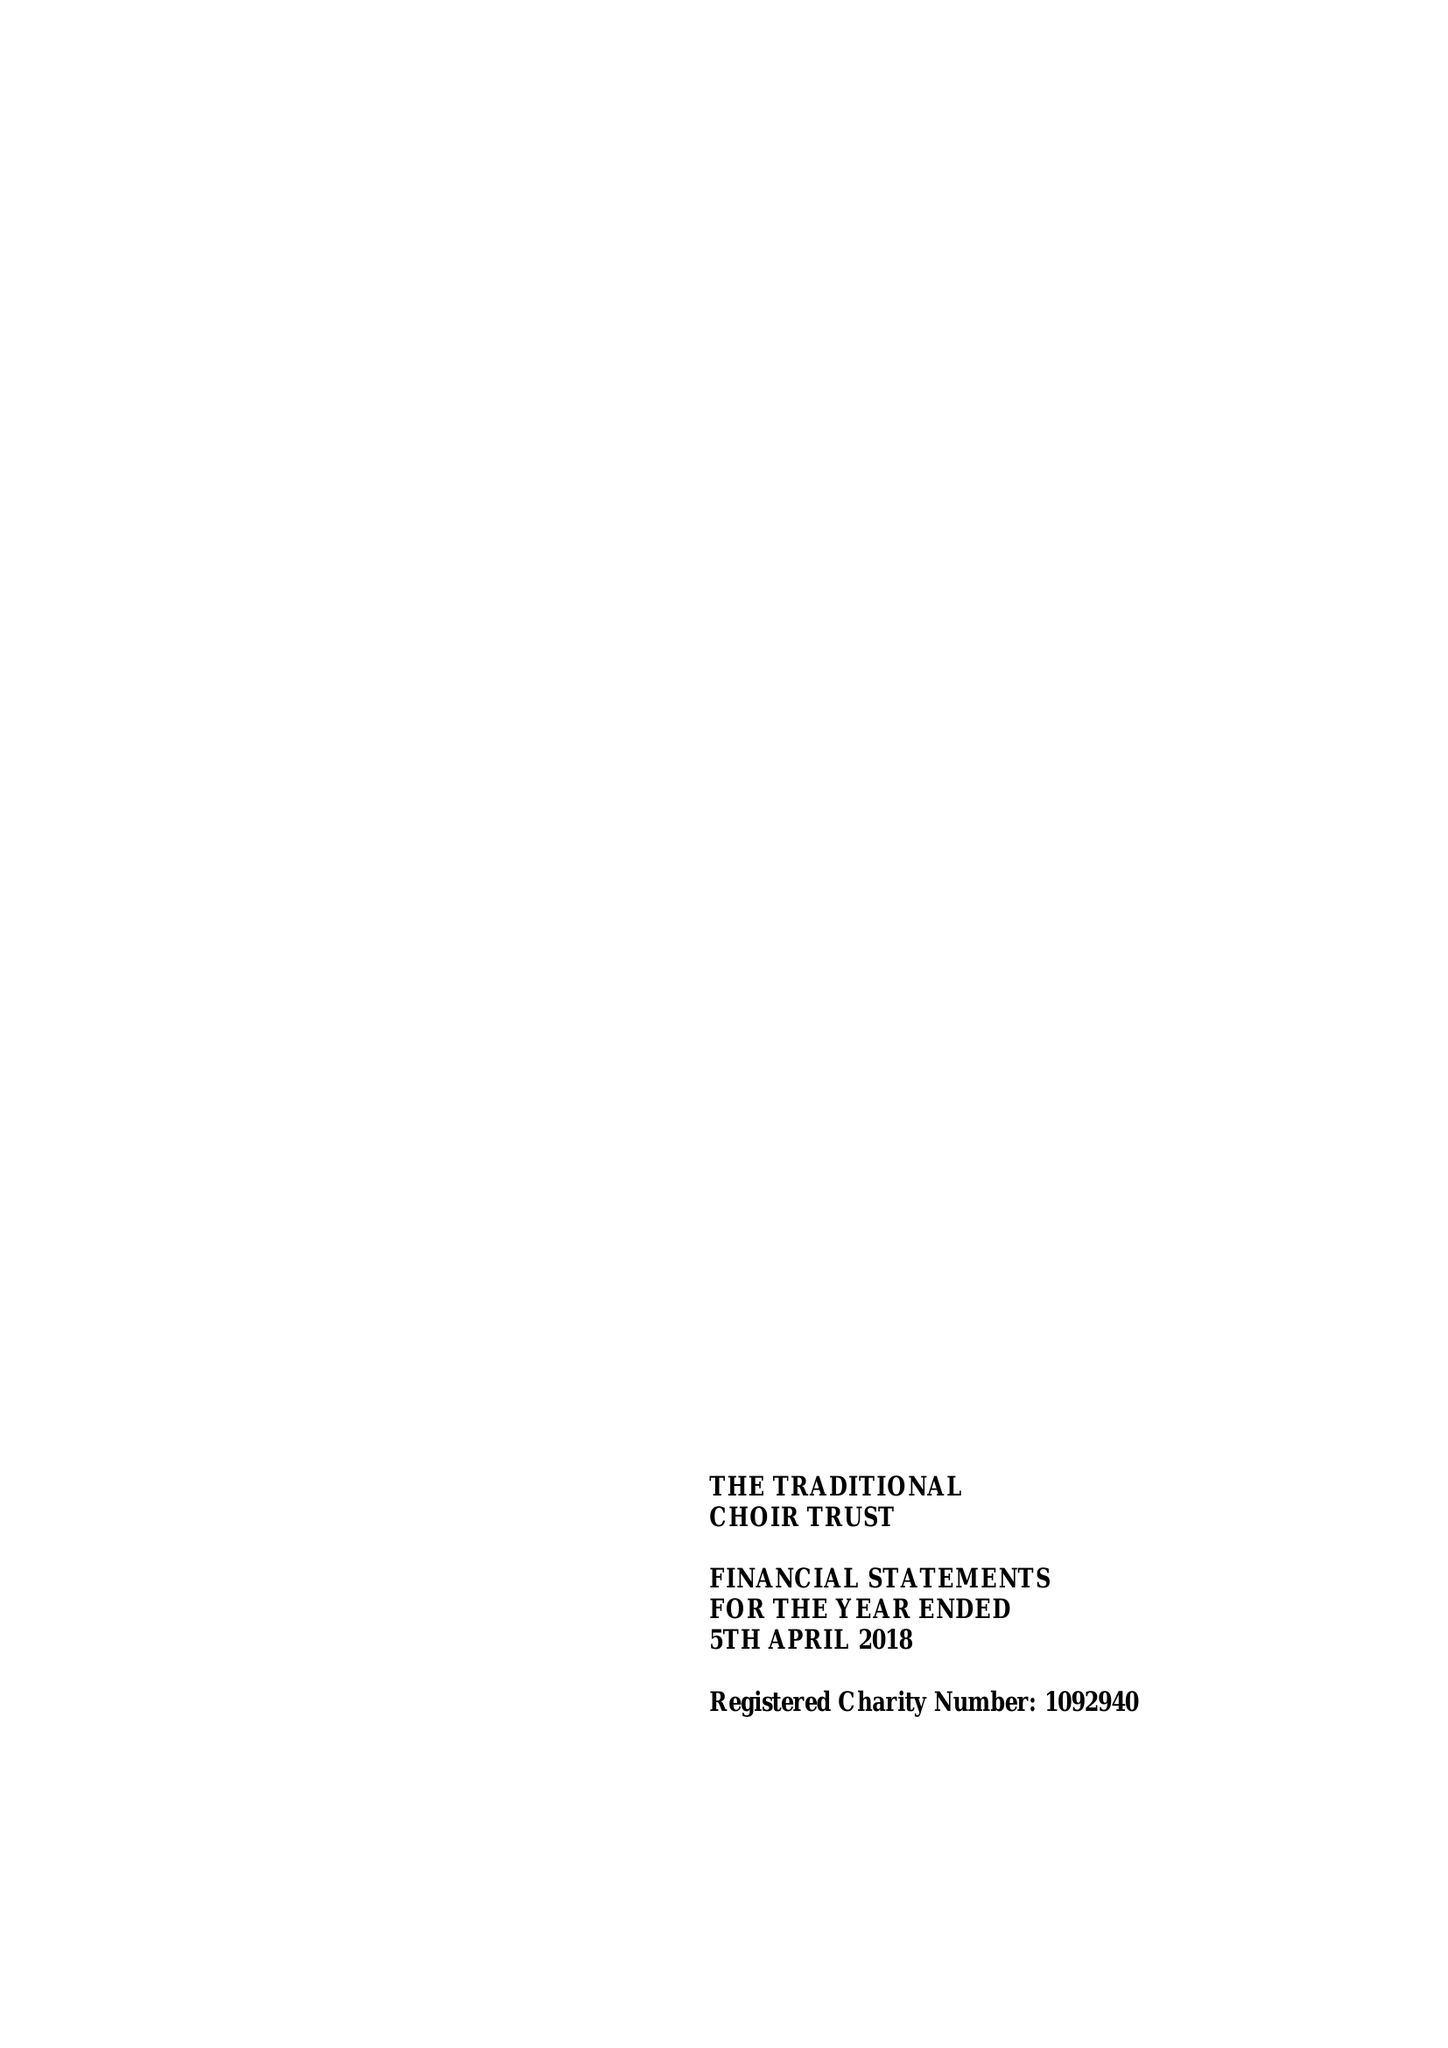What is the value for the address__post_town?
Answer the question using a single word or phrase. CHICHESTER 